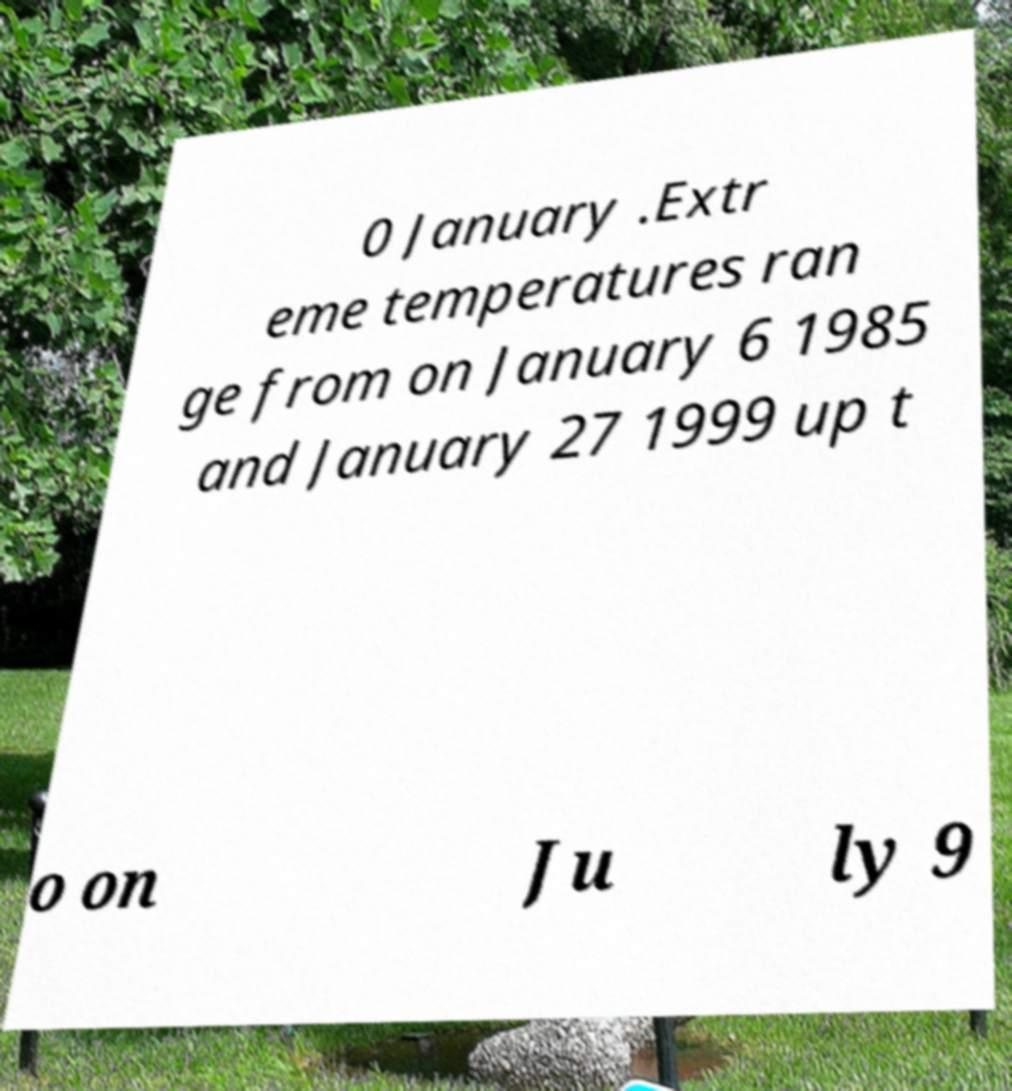Could you assist in decoding the text presented in this image and type it out clearly? 0 January .Extr eme temperatures ran ge from on January 6 1985 and January 27 1999 up t o on Ju ly 9 